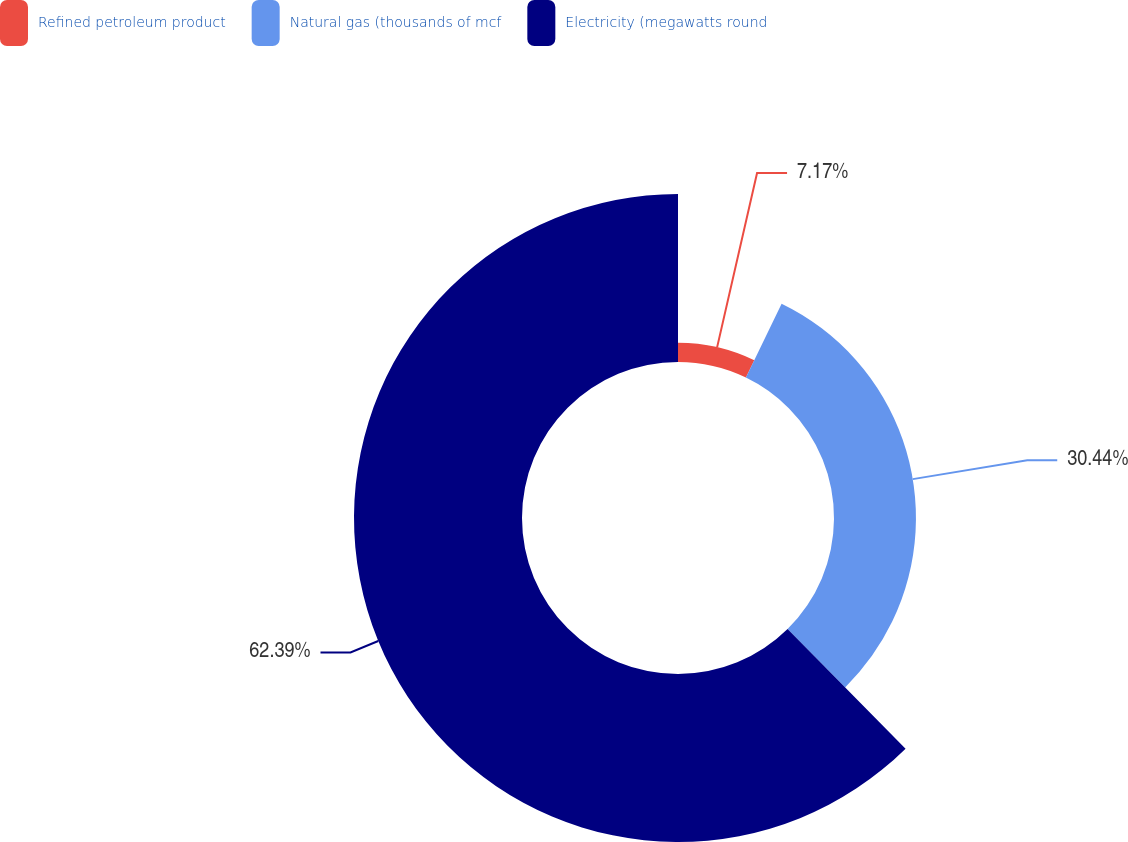Convert chart to OTSL. <chart><loc_0><loc_0><loc_500><loc_500><pie_chart><fcel>Refined petroleum product<fcel>Natural gas (thousands of mcf<fcel>Electricity (megawatts round<nl><fcel>7.17%<fcel>30.44%<fcel>62.4%<nl></chart> 